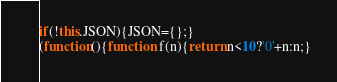Convert code to text. <code><loc_0><loc_0><loc_500><loc_500><_JavaScript_>
if(!this.JSON){JSON={};}
(function(){function f(n){return n<10?'0'+n:n;}</code> 